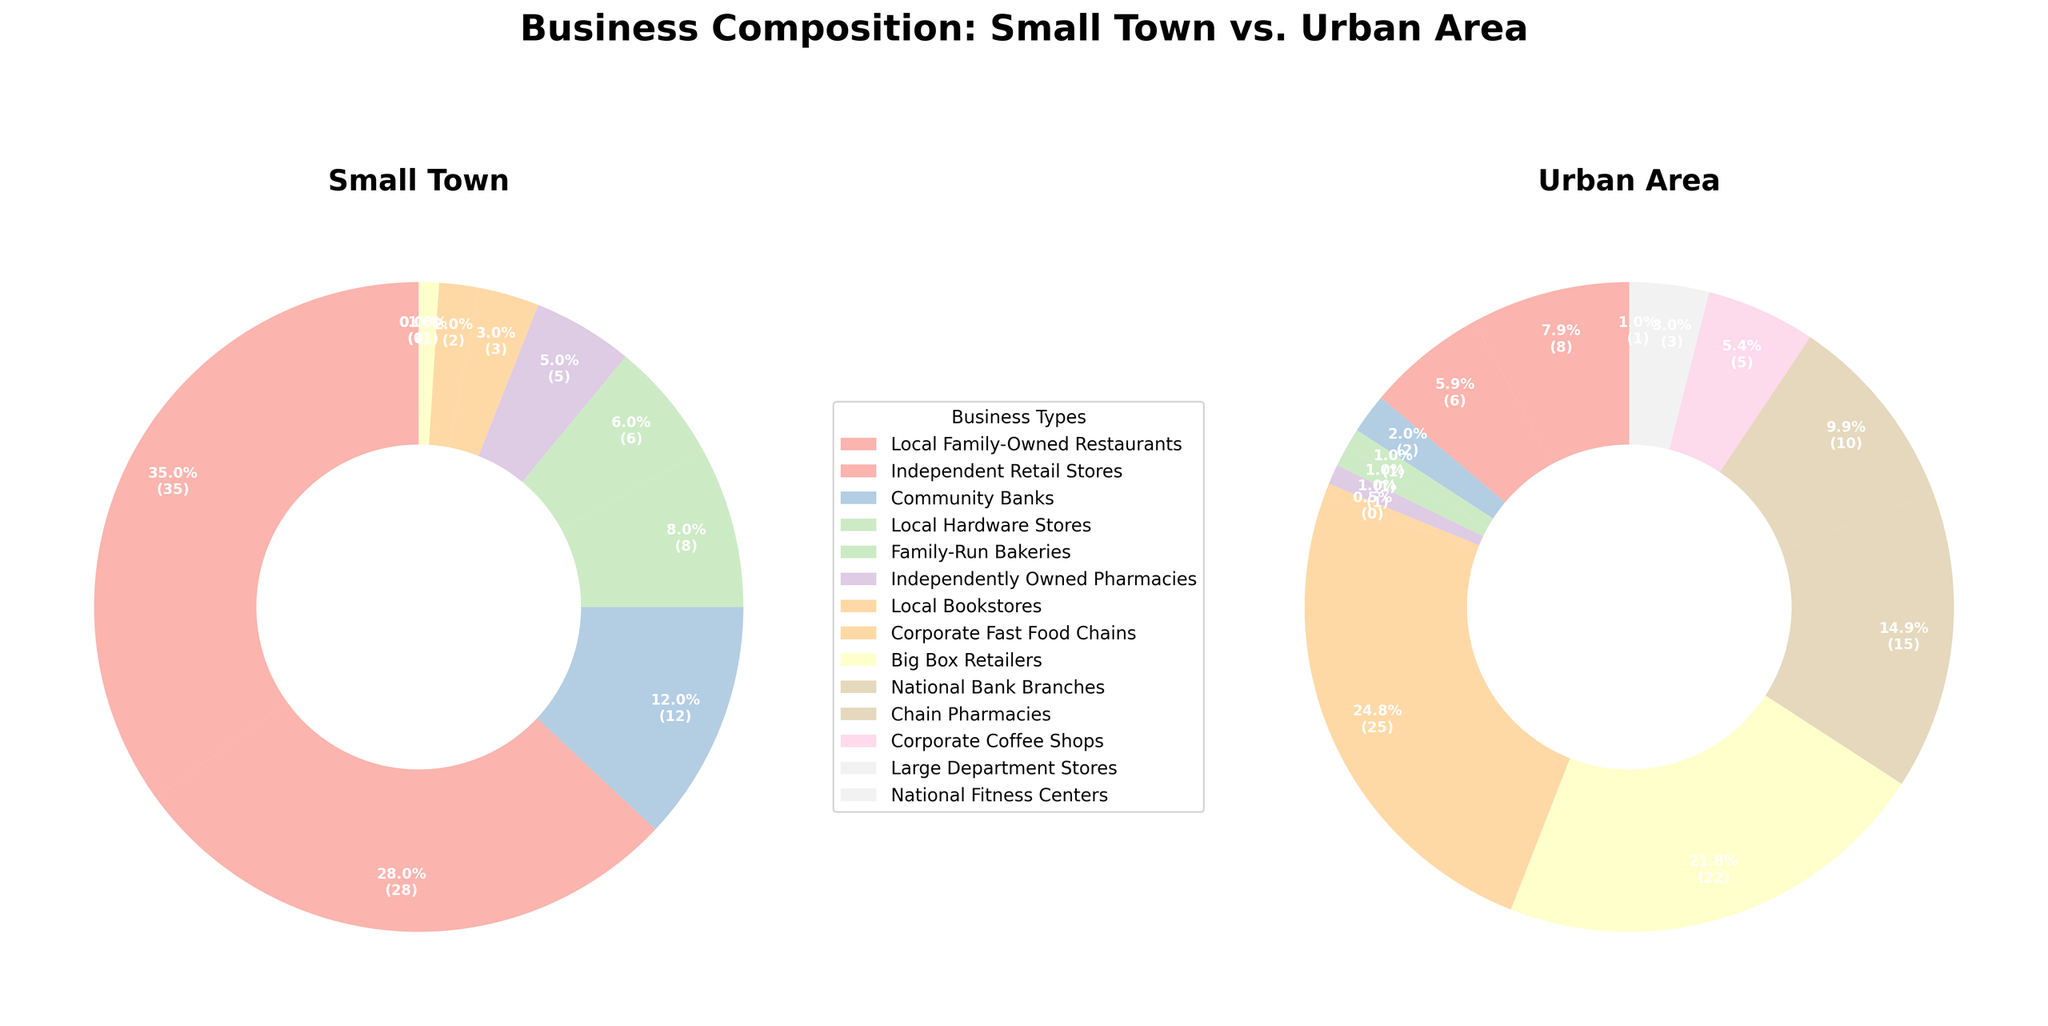What is the combined percentage of Local Family-Owned Restaurants and Independent Retail Stores in small towns? The percentage of Local Family-Owned Restaurants in small towns is 35% and the percentage of Independent Retail Stores is 28%. Adding these two percentages gives 35% + 28% = 63%.
Answer: 63% What percentage difference can be observed between Local Family-Owned Restaurants and Corporate Fast Food Chains in urban areas? The percentage of Local Family-Owned Restaurants in urban areas is 8%, while the percentage for Corporate Fast Food Chains is 25%. The difference is 25% - 8% = 17%.
Answer: 17% Which business type is uniquely present in urban areas but not in small towns? By comparing the two pie charts, we see that National Bank Branches, Chain Pharmacies, Corporate Coffee Shops, Large Department Stores, and National Fitness Centers are present only in urban areas.
Answer: National Bank Branches, Chain Pharmacies, Corporate Coffee Shops, Large Department Stores, National Fitness Centers How do Local Hardware Stores in small towns compare to those in urban areas in terms of percentages? Local Hardware Stores comprise 8% in small towns and 1% in urban areas. Therefore, they form a larger percentage in small towns.
Answer: Larger in small towns What is the visual indication that corporate chains dominate urban areas more than small towns? The urban area pie chart has sectors representing Corporate Fast Food Chains (25%), Big Box Retailers (22%), and National Bank Branches (15%), whereas such corporate chains are either absent or form a very small part of the small town pie chart.
Answer: Larger sectors in urban area What is the percentage of family-run bakeries in small towns? In the small town pie chart, the sector for Family-Run Bakeries is 6%.
Answer: 6% Calculate the total percentage of businesses categorized under corporate chains in urban areas. Adding up the percentages of Corporate Fast Food Chains (25%), Big Box Retailers (22%), National Bank Branches (15%), Chain Pharmacies (10%), Corporate Coffee Shops (5.5%), Large Department Stores (3%), and National Fitness Centers (1%): 25% + 22% + 15% + 10% + 5.5% + 3% + 1% = 81.5%.
Answer: 81.5% What visual feature distinguishes the business composition in small towns from urban areas? The small town pie chart predominantly shows larger segments for Local Family-Owned Restaurants and Independent Retail Stores, whereas the urban area pie chart shows larger segments for Corporate Fast Food Chains and Big Box Retailers.
Answer: Larger local business segments in small towns Which business type has the smallest presence in small towns and urban areas, and what is its percentage? The business type with the smallest presence in both small towns and urban areas is National Fitness Centers, with 0% in small towns and 1% in urban areas.
Answer: National Fitness Centers, 0% (small towns), 1% (urban areas) 